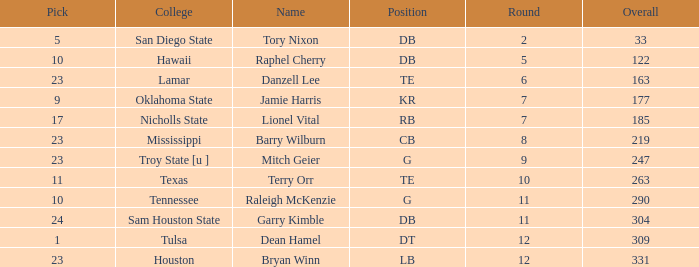How many Picks have an Overall smaller than 304, and a Position of g, and a Round smaller than 11? 1.0. 